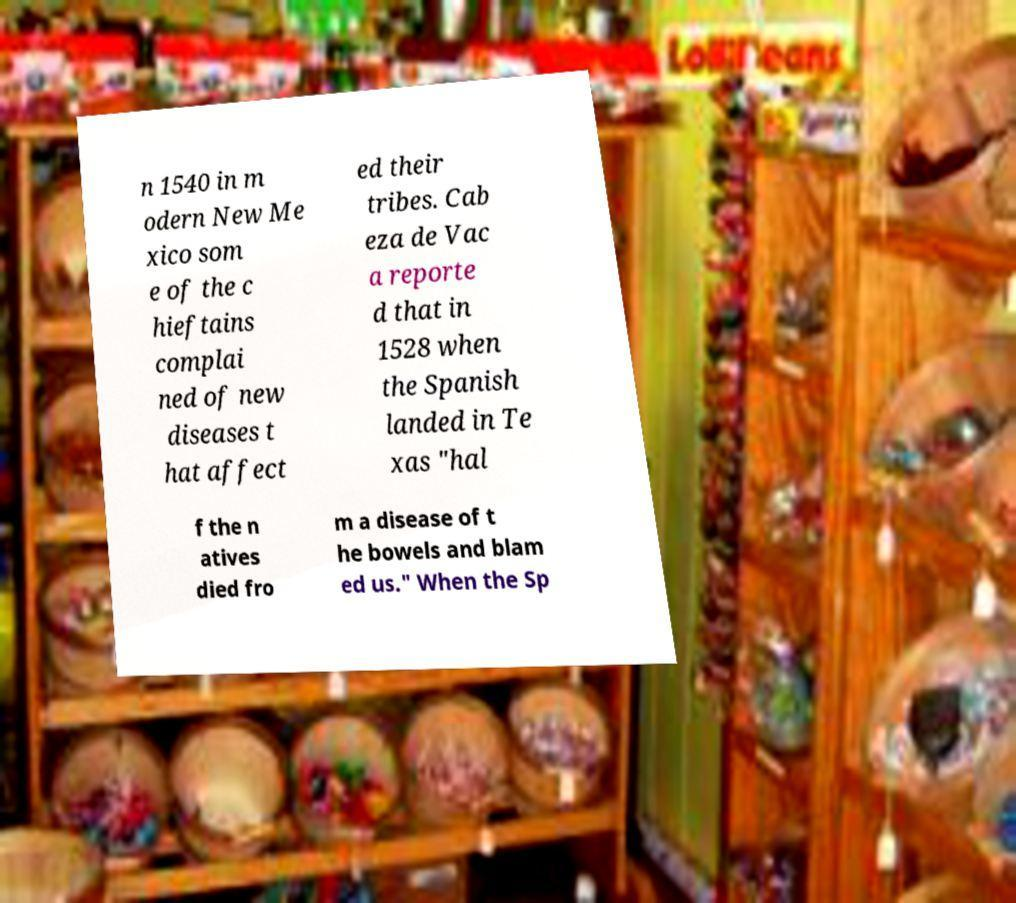I need the written content from this picture converted into text. Can you do that? n 1540 in m odern New Me xico som e of the c hieftains complai ned of new diseases t hat affect ed their tribes. Cab eza de Vac a reporte d that in 1528 when the Spanish landed in Te xas "hal f the n atives died fro m a disease of t he bowels and blam ed us." When the Sp 